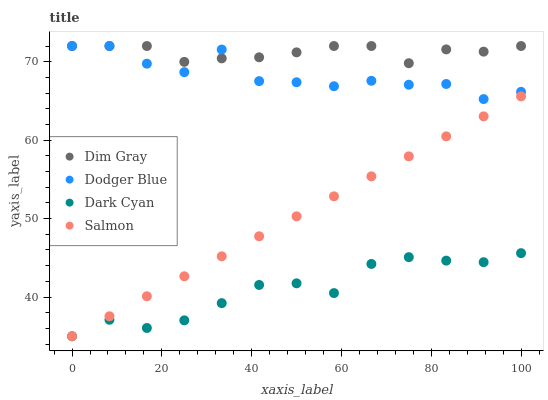Does Dark Cyan have the minimum area under the curve?
Answer yes or no. Yes. Does Dim Gray have the maximum area under the curve?
Answer yes or no. Yes. Does Salmon have the minimum area under the curve?
Answer yes or no. No. Does Salmon have the maximum area under the curve?
Answer yes or no. No. Is Salmon the smoothest?
Answer yes or no. Yes. Is Dodger Blue the roughest?
Answer yes or no. Yes. Is Dim Gray the smoothest?
Answer yes or no. No. Is Dim Gray the roughest?
Answer yes or no. No. Does Dark Cyan have the lowest value?
Answer yes or no. Yes. Does Dim Gray have the lowest value?
Answer yes or no. No. Does Dodger Blue have the highest value?
Answer yes or no. Yes. Does Salmon have the highest value?
Answer yes or no. No. Is Salmon less than Dodger Blue?
Answer yes or no. Yes. Is Dim Gray greater than Dark Cyan?
Answer yes or no. Yes. Does Salmon intersect Dark Cyan?
Answer yes or no. Yes. Is Salmon less than Dark Cyan?
Answer yes or no. No. Is Salmon greater than Dark Cyan?
Answer yes or no. No. Does Salmon intersect Dodger Blue?
Answer yes or no. No. 